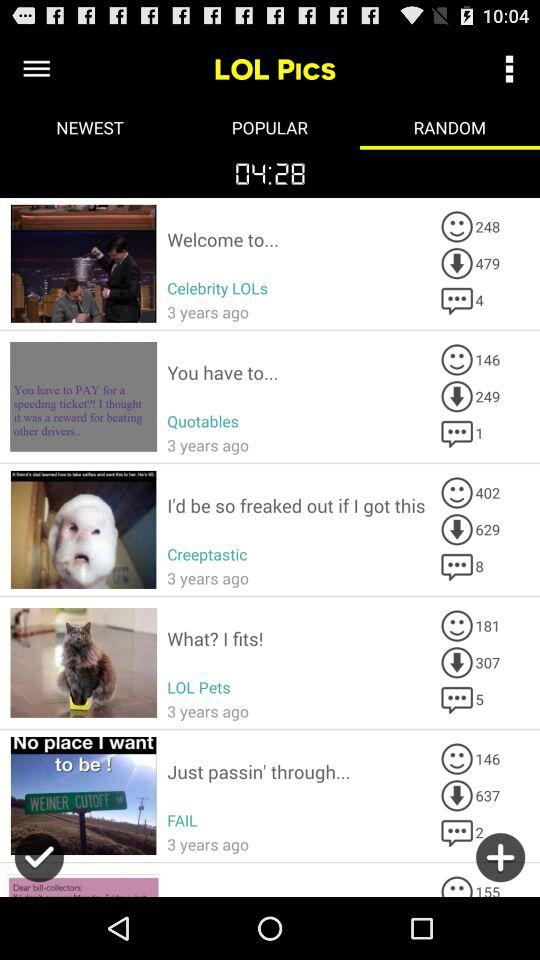How many people have reacted to the picture posted by "Quotables"? There are 146 people who have reacted. 